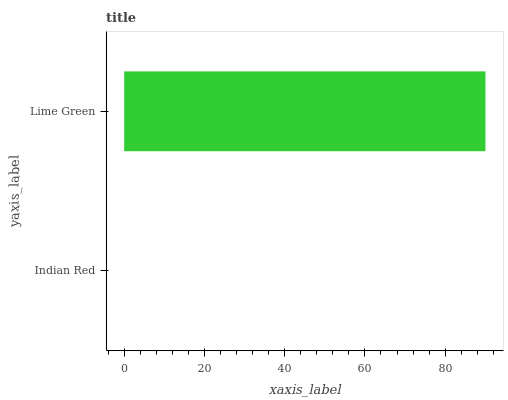Is Indian Red the minimum?
Answer yes or no. Yes. Is Lime Green the maximum?
Answer yes or no. Yes. Is Lime Green the minimum?
Answer yes or no. No. Is Lime Green greater than Indian Red?
Answer yes or no. Yes. Is Indian Red less than Lime Green?
Answer yes or no. Yes. Is Indian Red greater than Lime Green?
Answer yes or no. No. Is Lime Green less than Indian Red?
Answer yes or no. No. Is Lime Green the high median?
Answer yes or no. Yes. Is Indian Red the low median?
Answer yes or no. Yes. Is Indian Red the high median?
Answer yes or no. No. Is Lime Green the low median?
Answer yes or no. No. 